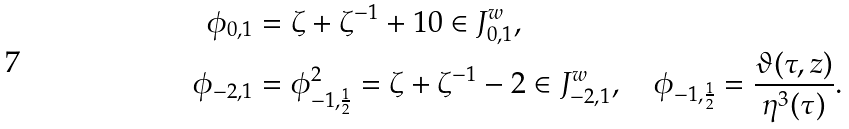Convert formula to latex. <formula><loc_0><loc_0><loc_500><loc_500>\phi _ { 0 , 1 } & = \zeta + \zeta ^ { - 1 } + 1 0 \in J _ { 0 , 1 } ^ { w } , \\ \phi _ { - 2 , 1 } & = \phi _ { - 1 , \frac { 1 } { 2 } } ^ { 2 } = \zeta + \zeta ^ { - 1 } - 2 \in J _ { - 2 , 1 } ^ { w } , \quad \phi _ { - 1 , \frac { 1 } { 2 } } = \frac { \vartheta ( \tau , z ) } { \eta ^ { 3 } ( \tau ) } .</formula> 